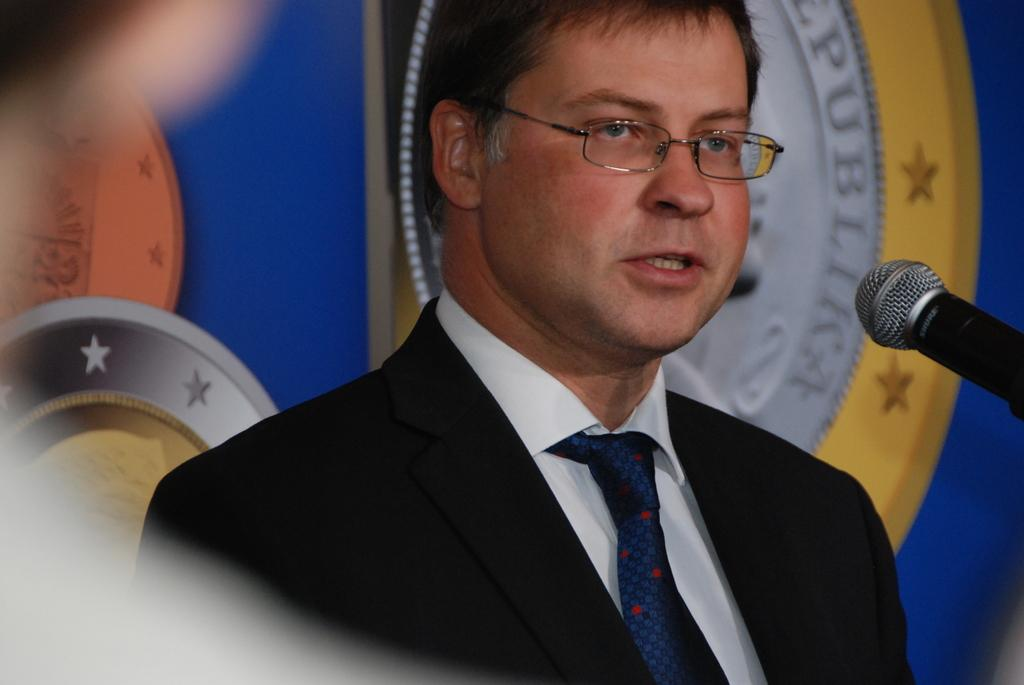Who is in the image? There is a man in the image. What is the man wearing? The man is wearing a black jacket, white shirt, and blue tie. What is the man doing in the image? The man is talking. What object is in front of the man? There is a microphone in front of the man. What can be seen in the background of the image? There is a blue poster with logos on it in the background. Can you see any hens in the image? There are no hens present in the image. What type of amusement park is depicted in the image? The image does not depict an amusement park; it features a man talking with a microphone in front of him. 